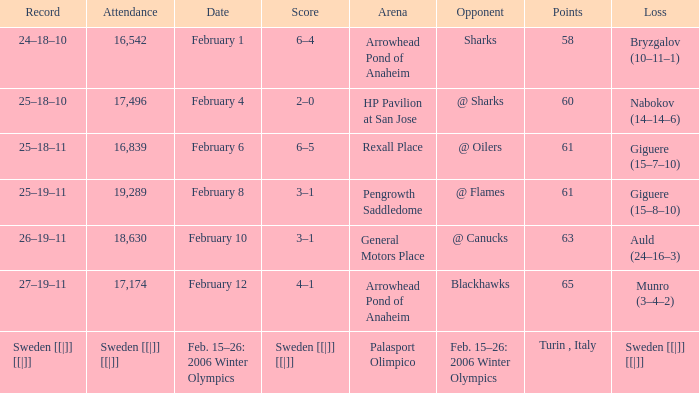What is the Arena when there were 65 points? Arrowhead Pond of Anaheim. 